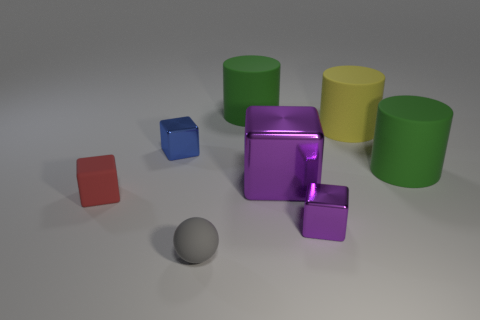Add 2 small red rubber cubes. How many objects exist? 10 Subtract all spheres. How many objects are left? 7 Add 8 tiny red rubber cubes. How many tiny red rubber cubes are left? 9 Add 2 red objects. How many red objects exist? 3 Subtract 0 yellow cubes. How many objects are left? 8 Subtract all cubes. Subtract all small red cubes. How many objects are left? 3 